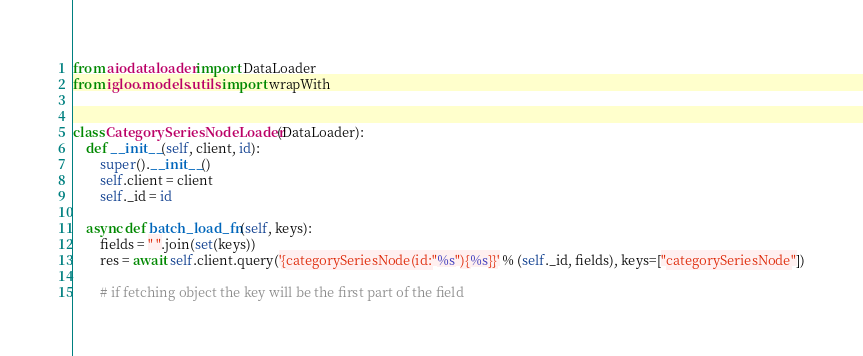<code> <loc_0><loc_0><loc_500><loc_500><_Python_>
from aiodataloader import DataLoader
from igloo.models.utils import wrapWith


class CategorySeriesNodeLoader(DataLoader):
    def __init__(self, client, id):
        super().__init__()
        self.client = client
        self._id = id

    async def batch_load_fn(self, keys):
        fields = " ".join(set(keys))
        res = await self.client.query('{categorySeriesNode(id:"%s"){%s}}' % (self._id, fields), keys=["categorySeriesNode"])

        # if fetching object the key will be the first part of the field</code> 